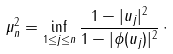<formula> <loc_0><loc_0><loc_500><loc_500>\mu _ { n } ^ { 2 } = \inf _ { 1 \leq j \leq n } \frac { 1 - | u _ { j } | ^ { 2 } } { 1 - | \phi ( u _ { j } ) | ^ { 2 } } \, \cdot</formula> 